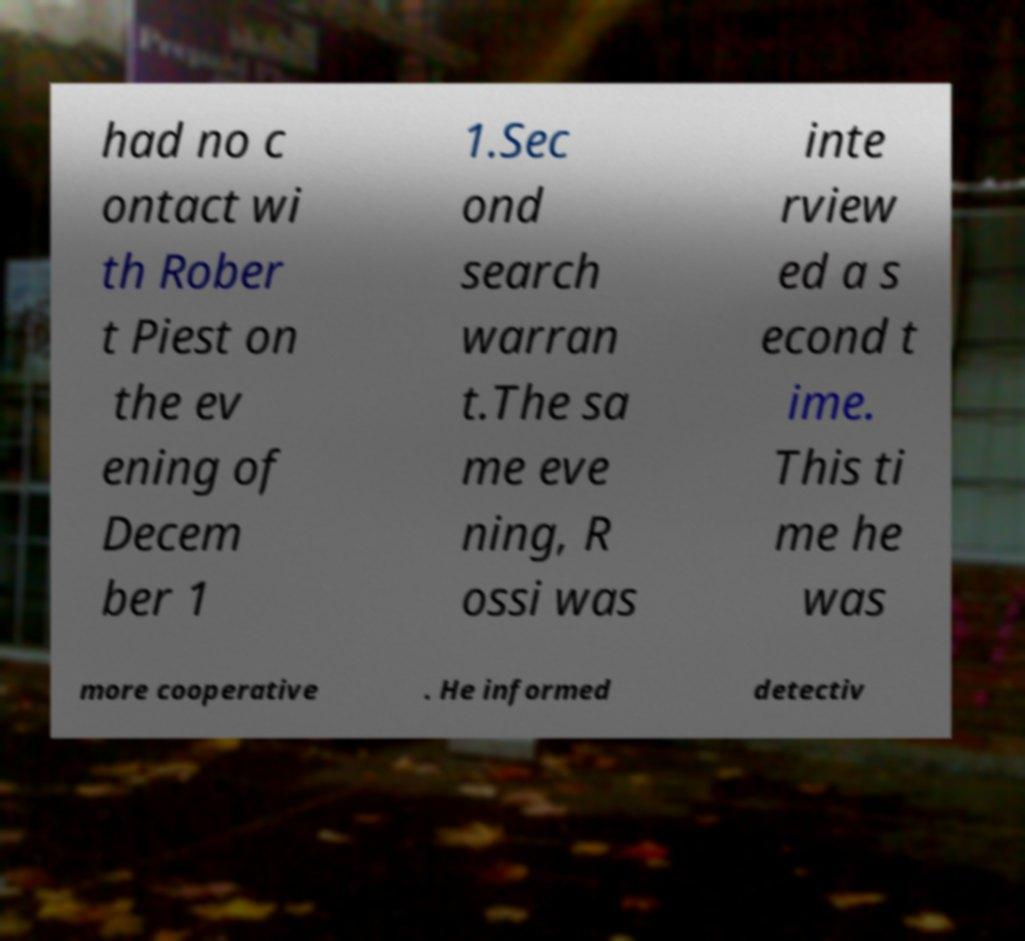Could you extract and type out the text from this image? had no c ontact wi th Rober t Piest on the ev ening of Decem ber 1 1.Sec ond search warran t.The sa me eve ning, R ossi was inte rview ed a s econd t ime. This ti me he was more cooperative . He informed detectiv 